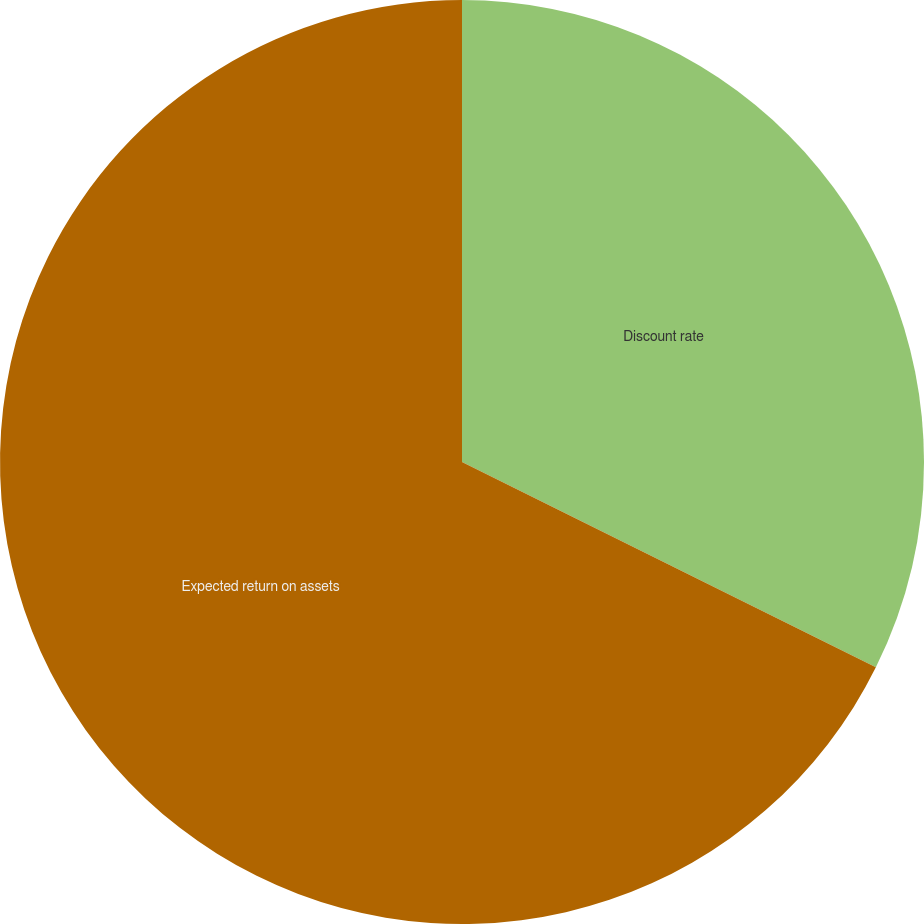Convert chart to OTSL. <chart><loc_0><loc_0><loc_500><loc_500><pie_chart><fcel>Discount rate<fcel>Expected return on assets<nl><fcel>32.33%<fcel>67.67%<nl></chart> 